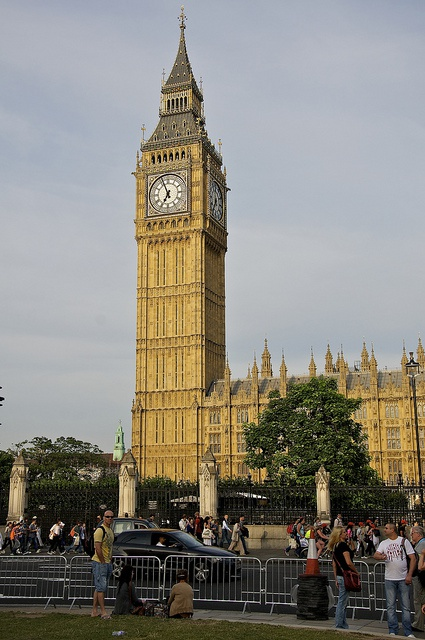Describe the objects in this image and their specific colors. I can see people in darkgray, black, gray, and maroon tones, car in darkgray, black, and gray tones, people in darkgray, black, gray, and maroon tones, people in darkgray, black, maroon, and gray tones, and people in darkgray, black, gray, and maroon tones in this image. 